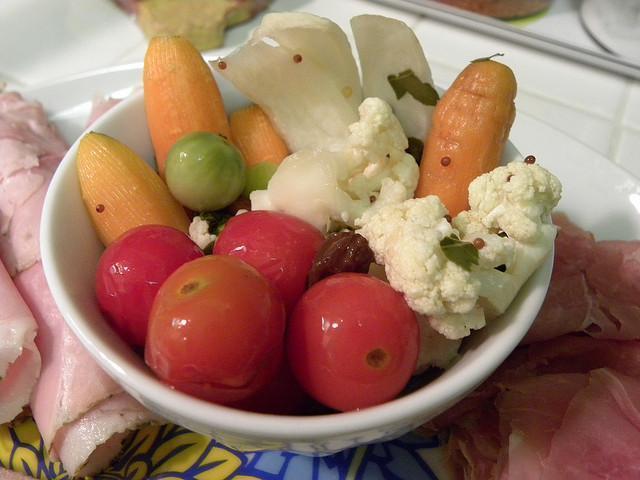How many carrots can you see?
Give a very brief answer. 3. 